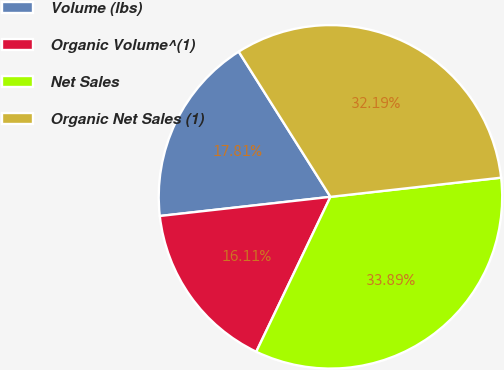Convert chart. <chart><loc_0><loc_0><loc_500><loc_500><pie_chart><fcel>Volume (lbs)<fcel>Organic Volume^(1)<fcel>Net Sales<fcel>Organic Net Sales (1)<nl><fcel>17.81%<fcel>16.11%<fcel>33.89%<fcel>32.19%<nl></chart> 